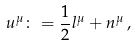<formula> <loc_0><loc_0><loc_500><loc_500>u ^ { \mu } \colon = { \frac { 1 } { 2 } } l ^ { \mu } + n ^ { \mu } { \, } ,</formula> 